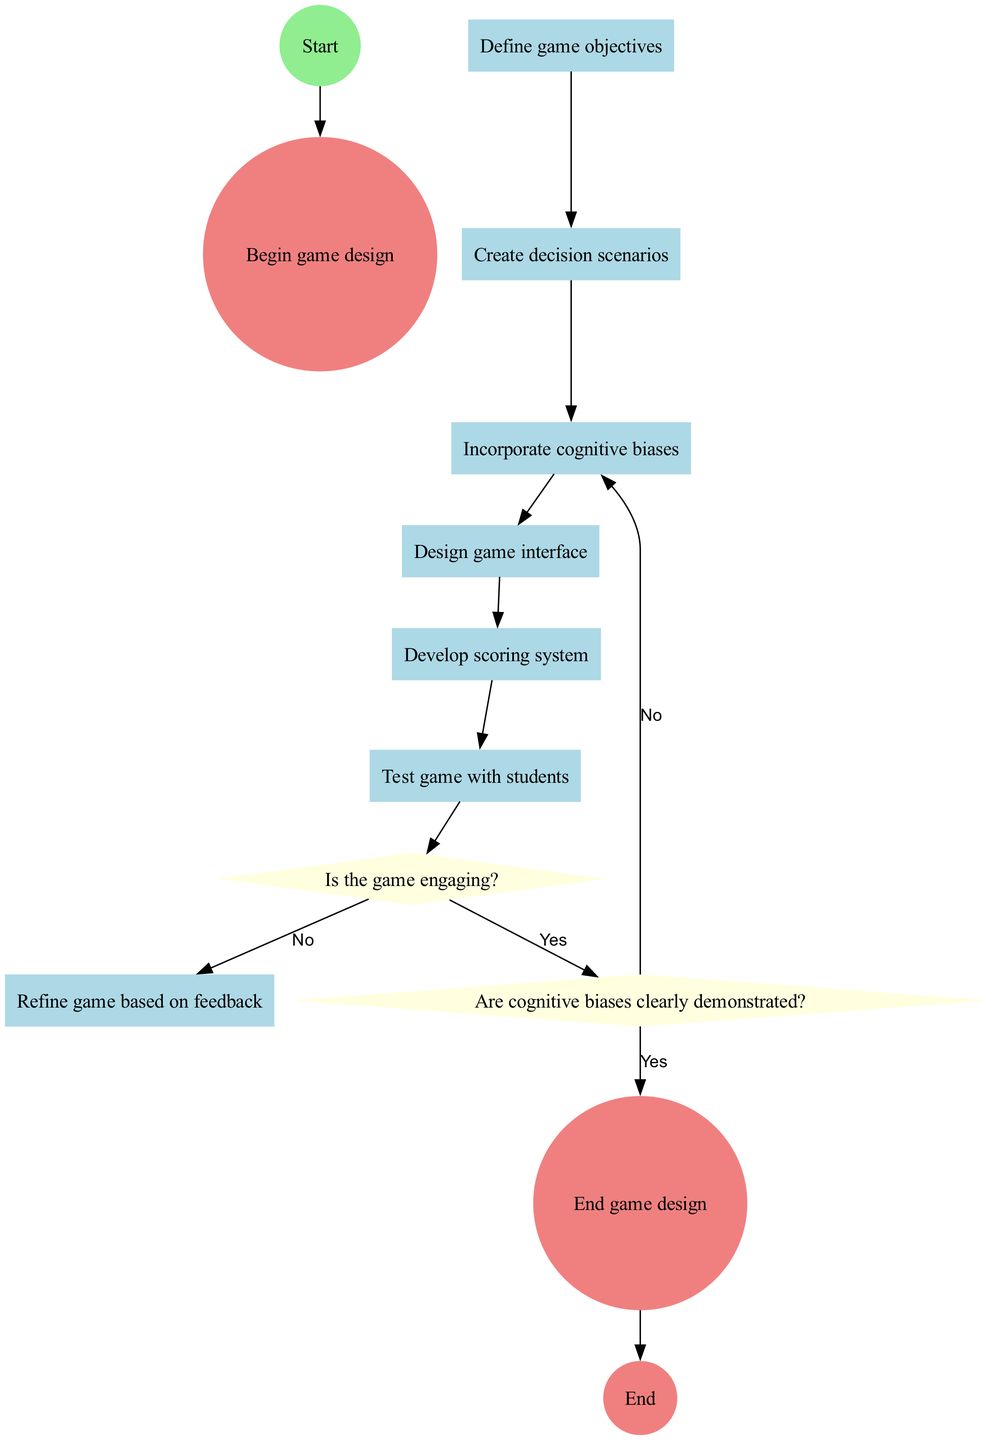What is the initial step in the game design process? The diagram indicates that the first activity listed is "Define game objectives," which illustrates what needs to be accomplished right at the start.
Answer: Define game objectives How many decision points are present in the diagram? The diagram displays two decision points: "Is the game engaging?" and "Are cognitive biases clearly demonstrated?" Therefore, there are a total of two decision points.
Answer: 2 After testing the game with students, what is the first question asked? Following the "Test game with students" activity, the next step shown in the diagram is a decision point asking "Is the game engaging?", indicating it is the first question after testing.
Answer: Is the game engaging? What happens if the game is not engaging? If the outcome of the decision "Is the game engaging?" is "No," the flow indicates that the next step is to "Refine game based on feedback," demonstrating how to address the issue of a lack of engagement.
Answer: Refine game based on feedback How many activities are there in total in the diagram? The diagram lists six activities, starting from "Define game objectives" to "Refine game based on feedback," which collectively count to a total of six distinct activities.
Answer: 6 If cognitive biases are not clearly demonstrated, what is the next step? The decision "Are cognitive biases clearly demonstrated?" leads to an alternative action if the answer is "No," which is to "Incorporate cognitive biases," showing how to improve that aspect of the game.
Answer: Incorporate cognitive biases What is the final output of the game design process? The diagram indicates that the end result of following all steps successfully is reaching the "End game design" node after ensuring that cognitive biases are clearly demonstrated, completing the game design process.
Answer: End game design Which activity immediately follows the statement of objectives? The flow in the diagram shows that after "Define game objectives," the next activity is "Create decision scenarios," illustrating the sequence of activities in the game design process.
Answer: Create decision scenarios What color represents decision points in the diagram? Decision points are represented in the diagram with a light yellow color, which distinguishes them visually from activities and start/end nodes.
Answer: Light yellow 